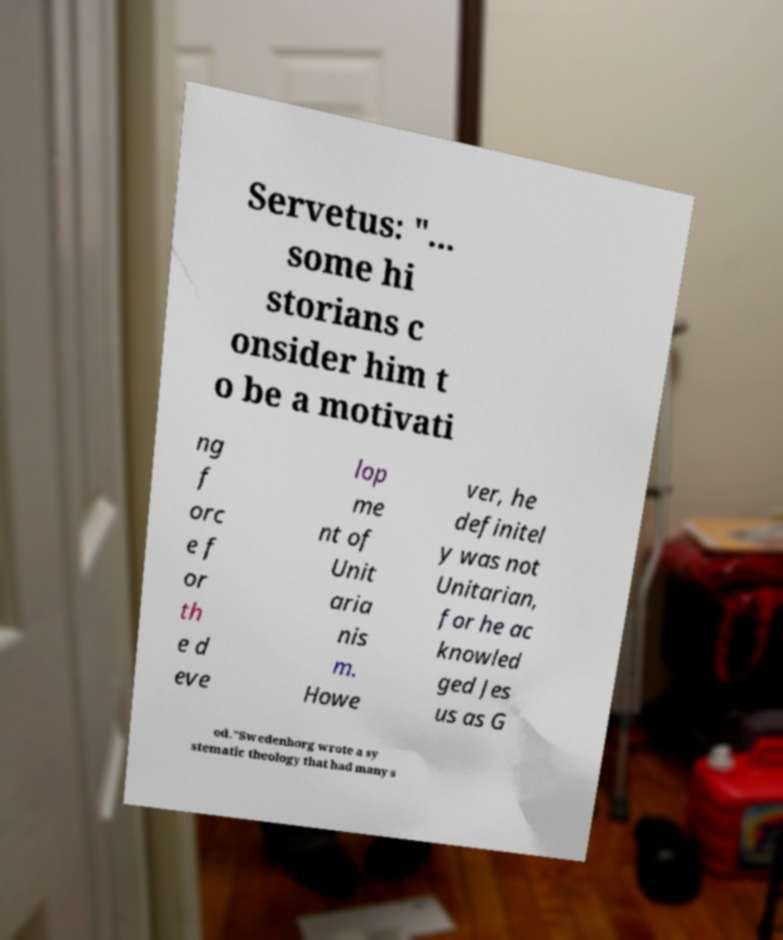Can you read and provide the text displayed in the image?This photo seems to have some interesting text. Can you extract and type it out for me? Servetus: "... some hi storians c onsider him t o be a motivati ng f orc e f or th e d eve lop me nt of Unit aria nis m. Howe ver, he definitel y was not Unitarian, for he ac knowled ged Jes us as G od."Swedenborg wrote a sy stematic theology that had many s 